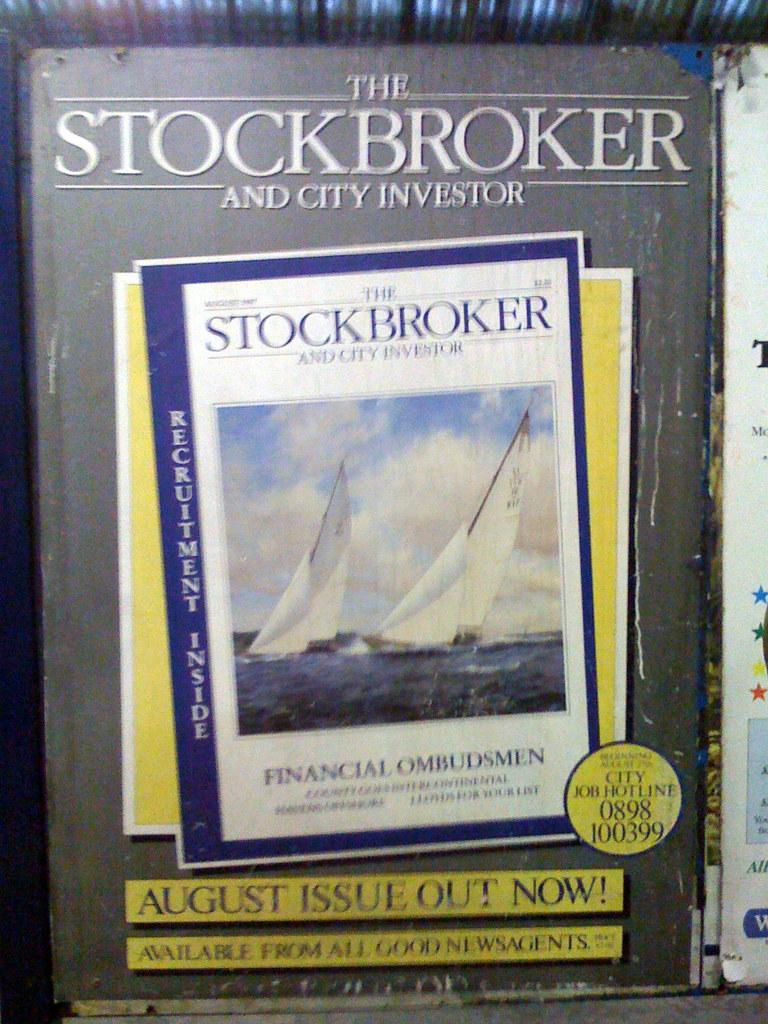<image>
Create a compact narrative representing the image presented. The front cover for the book The stockbroker and city investor. 